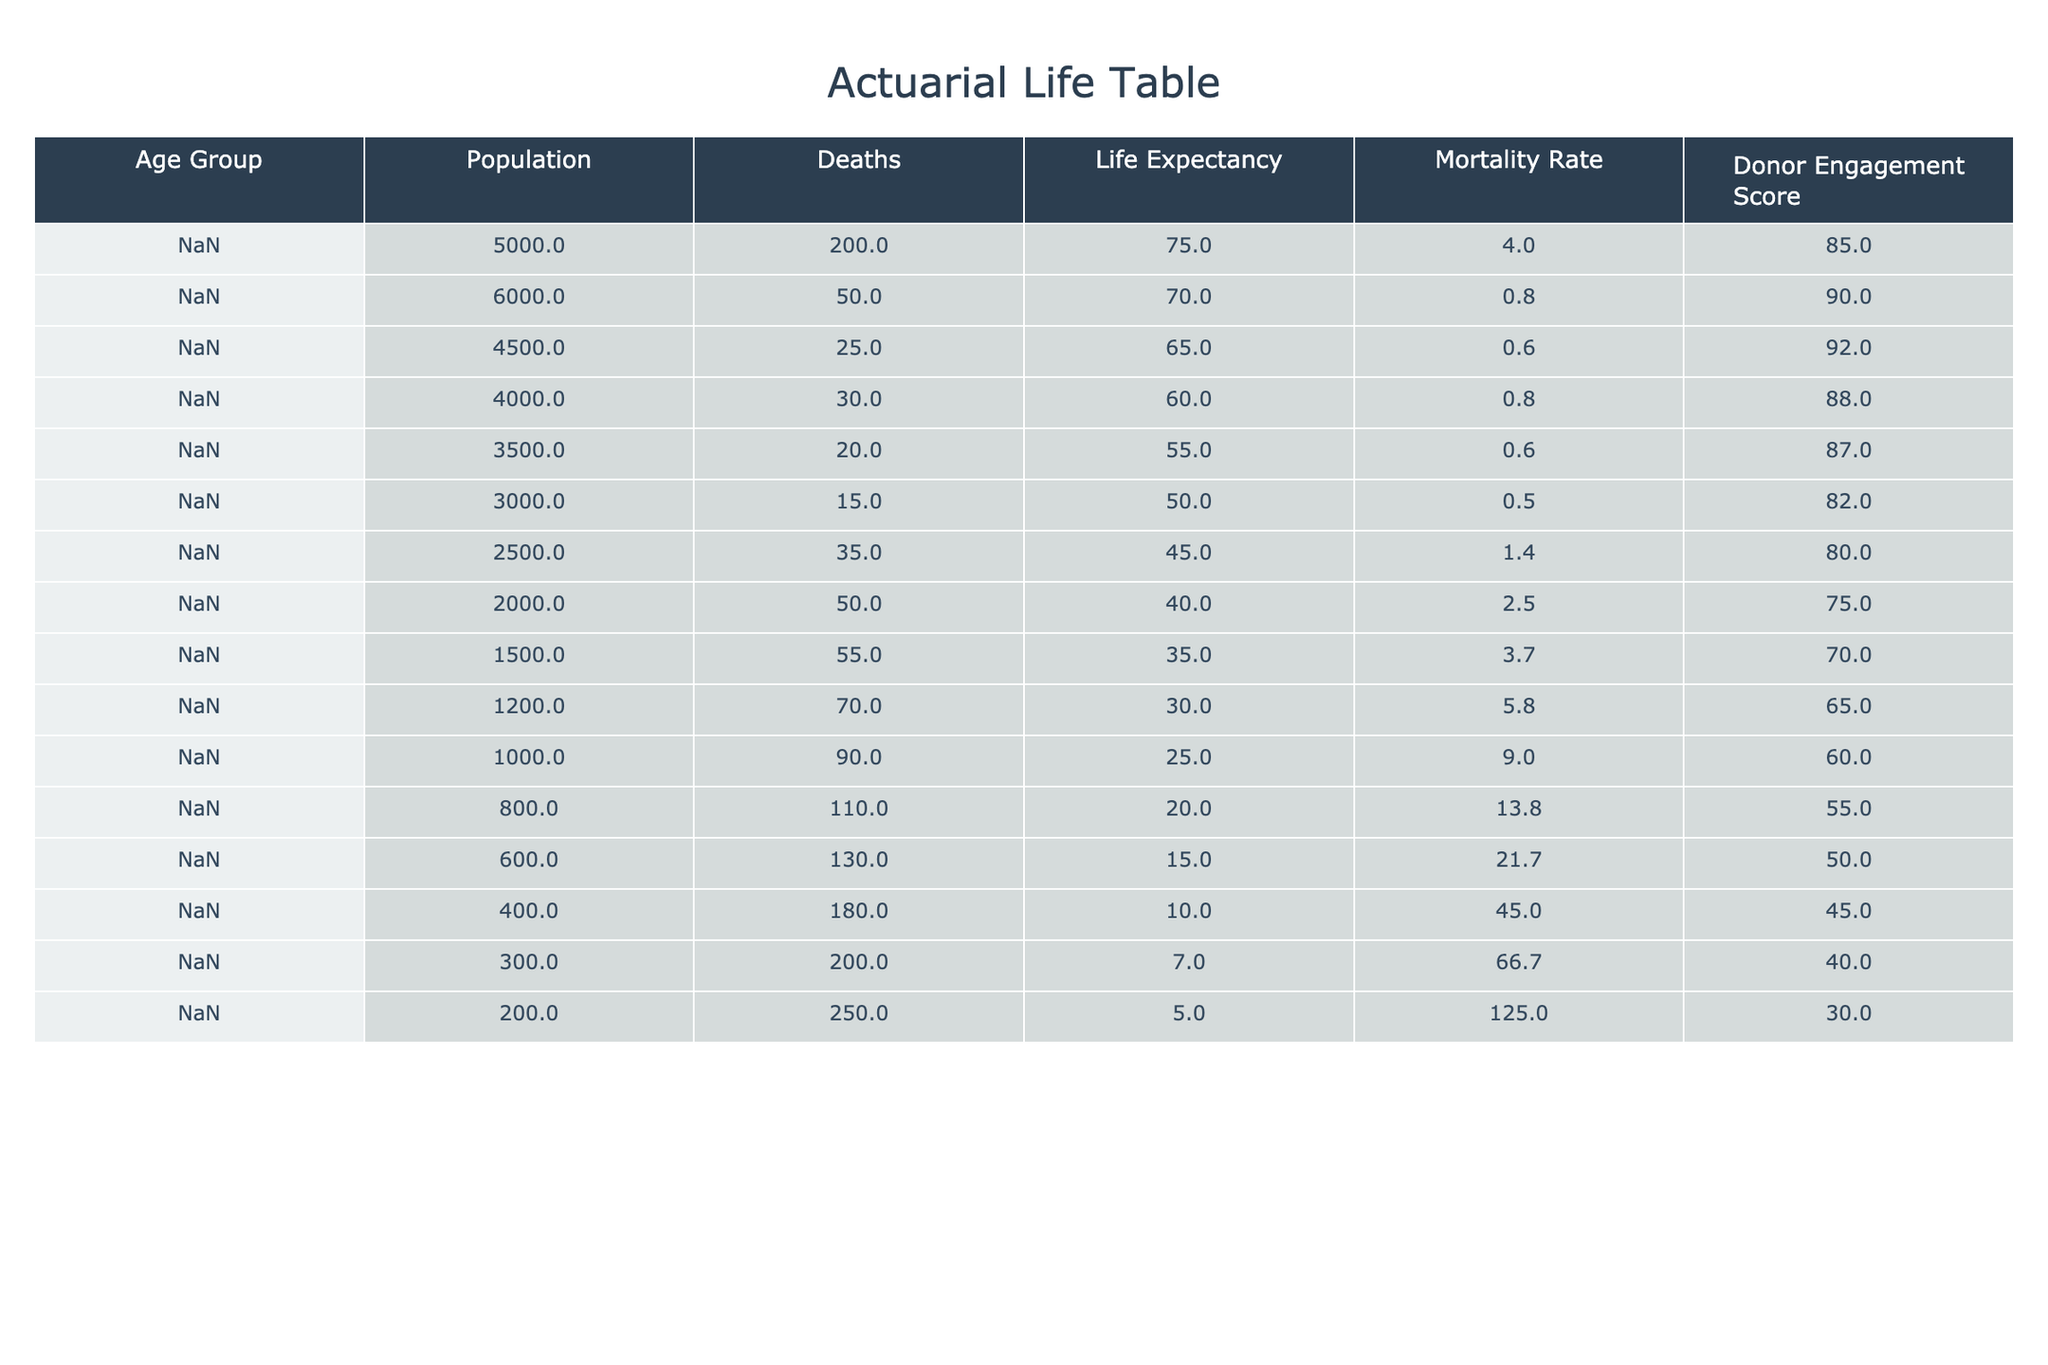What is the mortality rate for the age group 40-44? From the table, we can see the mortality rate for the age group 40-44 is listed directly under the "Mortality Rate" column. That value is 3.7.
Answer: 3.7 What is the life expectancy for beneficiaries aged 60-64? The life expectancy for beneficiaries aged 60-64 is provided in the table under the "Life Expectancy" column. Specifically, it states 15 years.
Answer: 15 Is the donor engagement score for the age group 75+ greater than 40? By examining the "Donor Engagement Score" for the age group 75+, we find it is 30. Since 30 is not greater than 40, the statement is false.
Answer: No What is the total number of deaths for beneficiaries aged 0-4 and 5-9 combined? The total number of deaths for the age group 0-4 is 200, and for the age group 5-9, it is 50. Adding these two figures gives us 200 + 50 = 250.
Answer: 250 Which age group has the highest mortality rate, and what is that rate? To find the age group with the highest mortality rate, we need to compare all the values in the "Mortality Rate" column. The highest rate is in the 75+ age group, which has a mortality rate of 125.0.
Answer: 125.0 How many total beneficiaries are there in the age group 55-59? The total number of beneficiaries for the age group 55-59 is explicitly shown in the table as 800.
Answer: 800 Is the average donor engagement score for beneficiaries aged 50-54 and 55-59 higher than 60? The donor engagement scores for ages 50-54 and 55-59 are 60 and 55, respectively. The average score can be calculated as (60 + 55)/2 = 57.5, which is not higher than 60.
Answer: No What is the difference in life expectancy between the age groups 15-19 and 35-39? The life expectancy for the age group 15-19 is 60 years, and for 35-39, it is 40 years. The difference is calculated as 60 - 40 = 20 years.
Answer: 20 How many people aged 70-74 died? According to the table, 200 people in the age group 70-74 died, as indicated in the "Deaths" column.
Answer: 200 